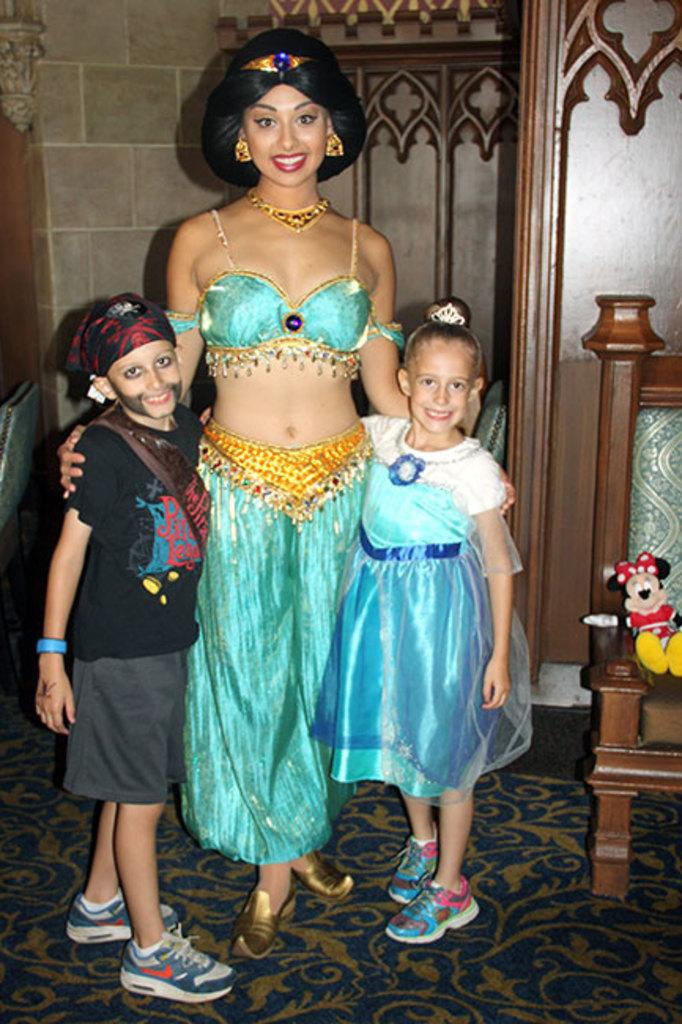How many people are in the image? There are three people in the image: a woman, a boy, and a girl. What are the people in the image doing? The woman, boy, and girl are standing. What can be seen on a chair in the image? There is a toy on a chair in the image. What is visible in the background of the image? There is a wall in the background of the image. Where is the receipt for the toy located in the image? There is no receipt present in the image. What type of cushion is on the chair with the toy? There is no cushion mentioned or visible in the image. 